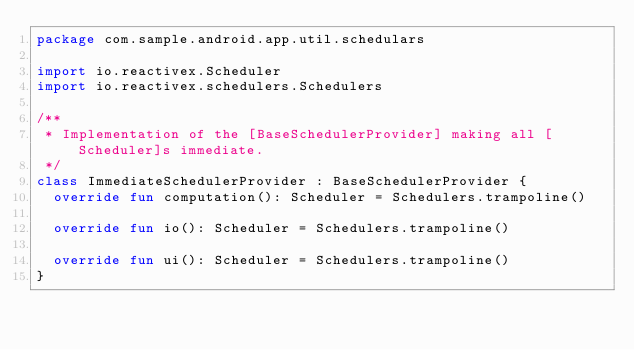<code> <loc_0><loc_0><loc_500><loc_500><_Kotlin_>package com.sample.android.app.util.schedulars

import io.reactivex.Scheduler
import io.reactivex.schedulers.Schedulers

/**
 * Implementation of the [BaseSchedulerProvider] making all [Scheduler]s immediate.
 */
class ImmediateSchedulerProvider : BaseSchedulerProvider {
  override fun computation(): Scheduler = Schedulers.trampoline()

  override fun io(): Scheduler = Schedulers.trampoline()

  override fun ui(): Scheduler = Schedulers.trampoline()
}
</code> 